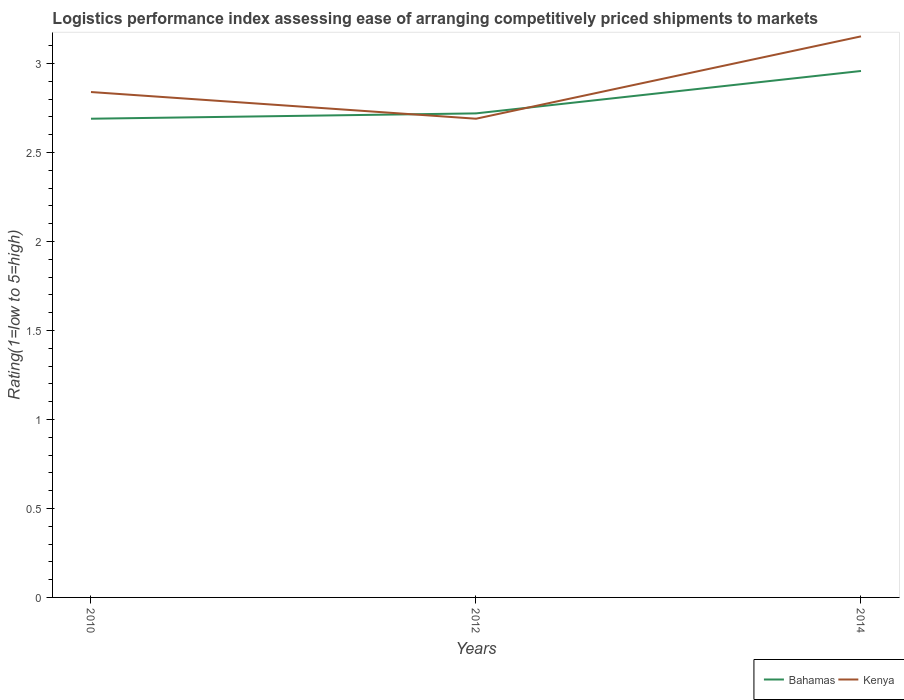Does the line corresponding to Bahamas intersect with the line corresponding to Kenya?
Make the answer very short. Yes. Across all years, what is the maximum Logistic performance index in Bahamas?
Offer a terse response. 2.69. In which year was the Logistic performance index in Bahamas maximum?
Offer a very short reply. 2010. What is the total Logistic performance index in Bahamas in the graph?
Give a very brief answer. -0.27. What is the difference between the highest and the second highest Logistic performance index in Kenya?
Offer a terse response. 0.46. Does the graph contain any zero values?
Offer a terse response. No. What is the title of the graph?
Your answer should be compact. Logistics performance index assessing ease of arranging competitively priced shipments to markets. What is the label or title of the Y-axis?
Ensure brevity in your answer.  Rating(1=low to 5=high). What is the Rating(1=low to 5=high) of Bahamas in 2010?
Your answer should be very brief. 2.69. What is the Rating(1=low to 5=high) in Kenya in 2010?
Your answer should be very brief. 2.84. What is the Rating(1=low to 5=high) in Bahamas in 2012?
Make the answer very short. 2.72. What is the Rating(1=low to 5=high) in Kenya in 2012?
Give a very brief answer. 2.69. What is the Rating(1=low to 5=high) of Bahamas in 2014?
Offer a very short reply. 2.96. What is the Rating(1=low to 5=high) in Kenya in 2014?
Ensure brevity in your answer.  3.15. Across all years, what is the maximum Rating(1=low to 5=high) of Bahamas?
Your answer should be very brief. 2.96. Across all years, what is the maximum Rating(1=low to 5=high) in Kenya?
Give a very brief answer. 3.15. Across all years, what is the minimum Rating(1=low to 5=high) in Bahamas?
Offer a very short reply. 2.69. Across all years, what is the minimum Rating(1=low to 5=high) of Kenya?
Make the answer very short. 2.69. What is the total Rating(1=low to 5=high) in Bahamas in the graph?
Provide a succinct answer. 8.37. What is the total Rating(1=low to 5=high) in Kenya in the graph?
Offer a terse response. 8.68. What is the difference between the Rating(1=low to 5=high) of Bahamas in 2010 and that in 2012?
Offer a terse response. -0.03. What is the difference between the Rating(1=low to 5=high) of Kenya in 2010 and that in 2012?
Ensure brevity in your answer.  0.15. What is the difference between the Rating(1=low to 5=high) of Bahamas in 2010 and that in 2014?
Your answer should be very brief. -0.27. What is the difference between the Rating(1=low to 5=high) of Kenya in 2010 and that in 2014?
Provide a succinct answer. -0.31. What is the difference between the Rating(1=low to 5=high) in Bahamas in 2012 and that in 2014?
Make the answer very short. -0.24. What is the difference between the Rating(1=low to 5=high) in Kenya in 2012 and that in 2014?
Make the answer very short. -0.46. What is the difference between the Rating(1=low to 5=high) in Bahamas in 2010 and the Rating(1=low to 5=high) in Kenya in 2014?
Keep it short and to the point. -0.46. What is the difference between the Rating(1=low to 5=high) in Bahamas in 2012 and the Rating(1=low to 5=high) in Kenya in 2014?
Offer a terse response. -0.43. What is the average Rating(1=low to 5=high) in Bahamas per year?
Offer a very short reply. 2.79. What is the average Rating(1=low to 5=high) of Kenya per year?
Offer a very short reply. 2.89. In the year 2012, what is the difference between the Rating(1=low to 5=high) of Bahamas and Rating(1=low to 5=high) of Kenya?
Ensure brevity in your answer.  0.03. In the year 2014, what is the difference between the Rating(1=low to 5=high) in Bahamas and Rating(1=low to 5=high) in Kenya?
Ensure brevity in your answer.  -0.19. What is the ratio of the Rating(1=low to 5=high) in Bahamas in 2010 to that in 2012?
Your answer should be compact. 0.99. What is the ratio of the Rating(1=low to 5=high) in Kenya in 2010 to that in 2012?
Keep it short and to the point. 1.06. What is the ratio of the Rating(1=low to 5=high) of Bahamas in 2010 to that in 2014?
Offer a terse response. 0.91. What is the ratio of the Rating(1=low to 5=high) in Kenya in 2010 to that in 2014?
Your response must be concise. 0.9. What is the ratio of the Rating(1=low to 5=high) of Bahamas in 2012 to that in 2014?
Offer a very short reply. 0.92. What is the ratio of the Rating(1=low to 5=high) of Kenya in 2012 to that in 2014?
Your answer should be compact. 0.85. What is the difference between the highest and the second highest Rating(1=low to 5=high) of Bahamas?
Your answer should be compact. 0.24. What is the difference between the highest and the second highest Rating(1=low to 5=high) of Kenya?
Offer a terse response. 0.31. What is the difference between the highest and the lowest Rating(1=low to 5=high) of Bahamas?
Make the answer very short. 0.27. What is the difference between the highest and the lowest Rating(1=low to 5=high) in Kenya?
Give a very brief answer. 0.46. 